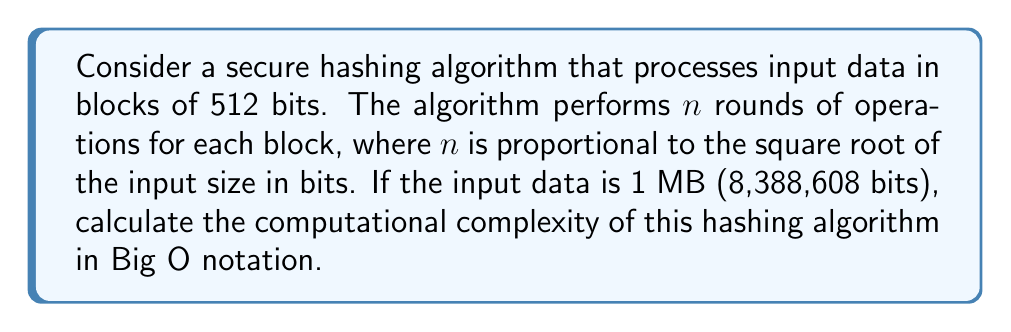Show me your answer to this math problem. To solve this problem, let's break it down step-by-step:

1. First, we need to determine the number of blocks:
   - Input size = 8,388,608 bits
   - Block size = 512 bits
   - Number of blocks = $\frac{8,388,608}{512} = 16,384$

2. Now, we need to calculate $n$, the number of rounds per block:
   - $n$ is proportional to $\sqrt{\text{input size}}$
   - $n = c \cdot \sqrt{8,388,608}$, where $c$ is some constant
   - $n = c \cdot 2,896$ (approx.)

3. For each block, the algorithm performs $n$ rounds of operations:
   - Operations per block = $c \cdot 2,896$

4. Total number of operations:
   - Total operations = Number of blocks × Operations per block
   - Total operations = $16,384 \cdot (c \cdot 2,896)$
   - Total operations = $47,448,064c$

5. In Big O notation, we ignore constants and focus on the growth rate:
   - The number of operations is linear with respect to the input size
   - The constant $c$ and the square root factor are absorbed into the linear term

Therefore, the computational complexity of this hashing algorithm is $O(m)$, where $m$ is the input size in bits.
Answer: $O(m)$, where $m$ is the input size in bits 